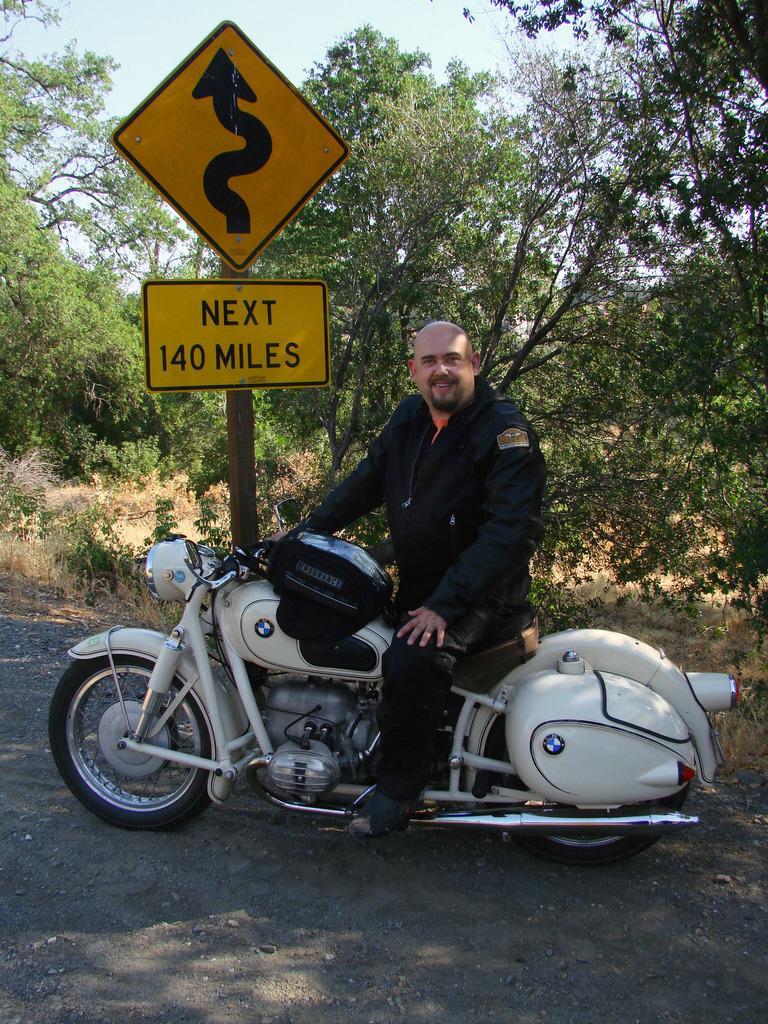How would you summarize this image in a sentence or two? in the center we can see man is smiling and he is sitting on the bike. And back we can see tree,sky,grass and sign board. 